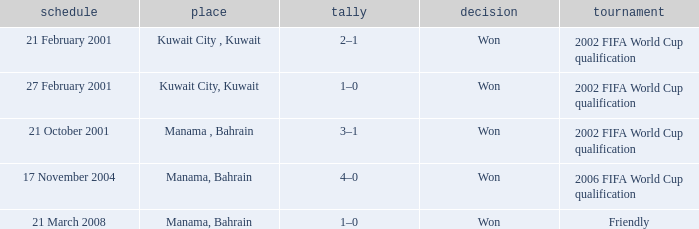On which date was the 2006 FIFA World Cup Qualification in Manama, Bahrain? 17 November 2004. 